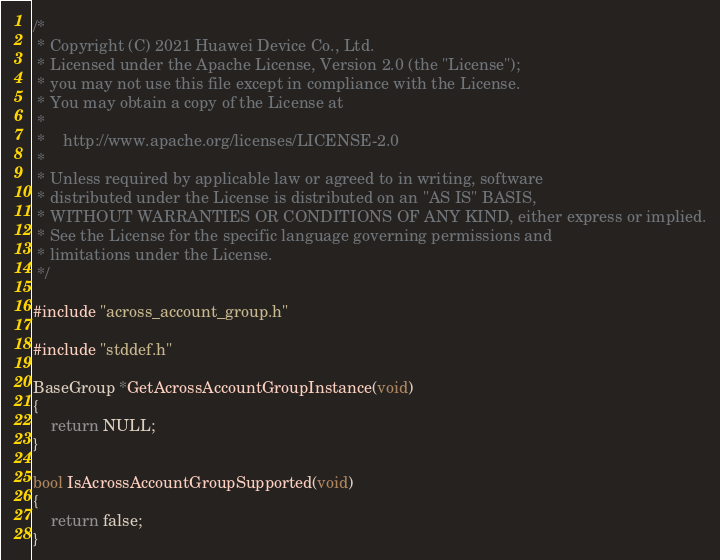Convert code to text. <code><loc_0><loc_0><loc_500><loc_500><_C_>/*
 * Copyright (C) 2021 Huawei Device Co., Ltd.
 * Licensed under the Apache License, Version 2.0 (the "License");
 * you may not use this file except in compliance with the License.
 * You may obtain a copy of the License at
 *
 *    http://www.apache.org/licenses/LICENSE-2.0
 *
 * Unless required by applicable law or agreed to in writing, software
 * distributed under the License is distributed on an "AS IS" BASIS,
 * WITHOUT WARRANTIES OR CONDITIONS OF ANY KIND, either express or implied.
 * See the License for the specific language governing permissions and
 * limitations under the License.
 */

#include "across_account_group.h"

#include "stddef.h"

BaseGroup *GetAcrossAccountGroupInstance(void)
{
    return NULL;
}

bool IsAcrossAccountGroupSupported(void)
{
    return false;
}</code> 